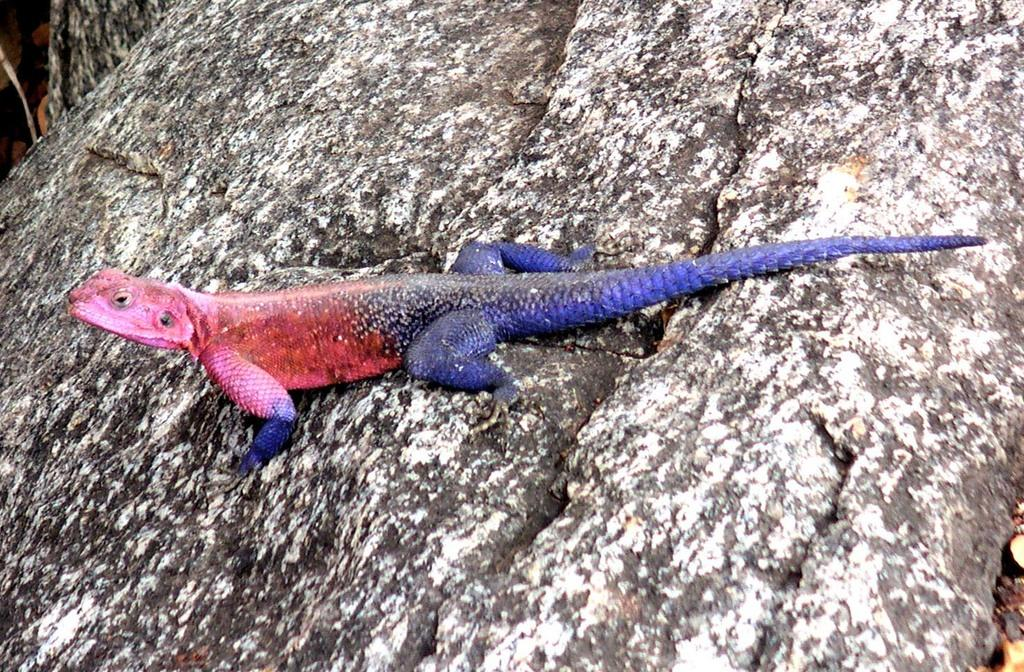What type of animal is in the image? There is a colorful reptile in the image. Where is the reptile located? The reptile is on a rock. What can be seen on the left side of the image? There are objects on the ground on the left side of the image. What can be seen on the right side of the image? There are objects on the ground on the right side of the image. What fact about the disgusting creature can be observed in the image? There is no mention of a disgusting creature in the image; it features a colorful reptile on a rock. 